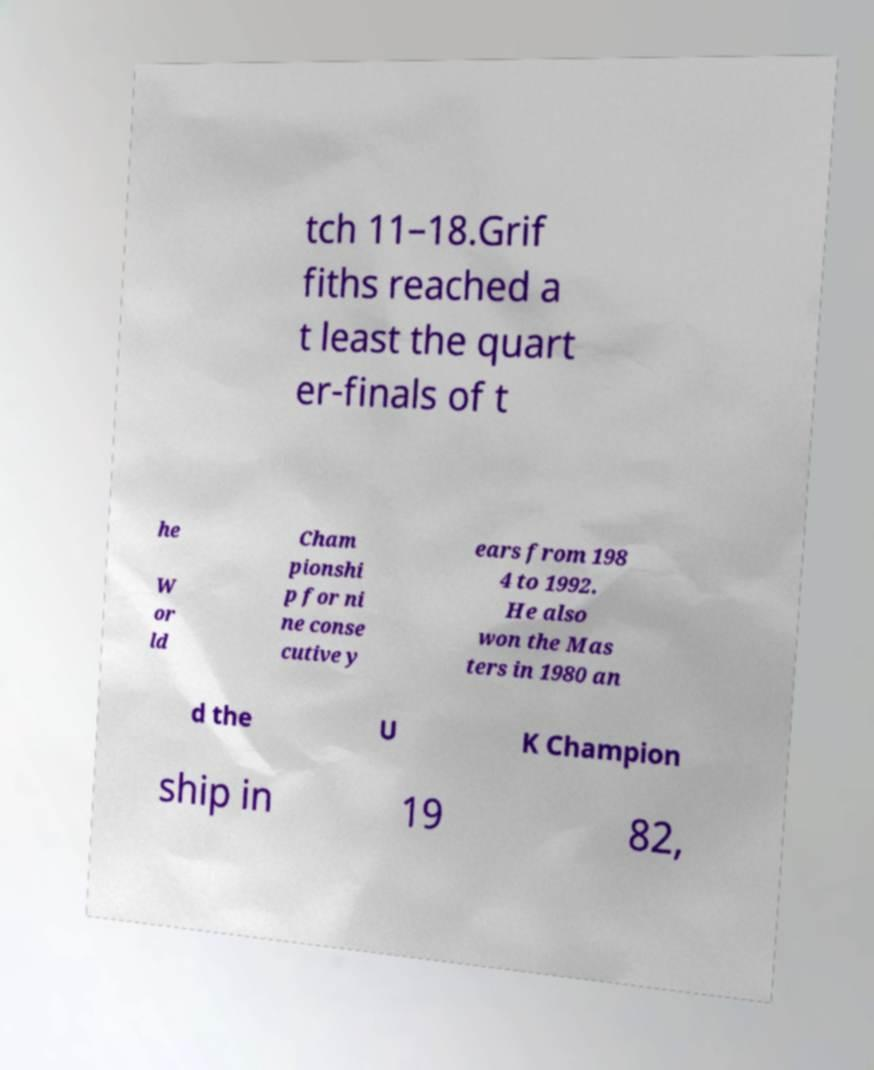What messages or text are displayed in this image? I need them in a readable, typed format. tch 11–18.Grif fiths reached a t least the quart er-finals of t he W or ld Cham pionshi p for ni ne conse cutive y ears from 198 4 to 1992. He also won the Mas ters in 1980 an d the U K Champion ship in 19 82, 